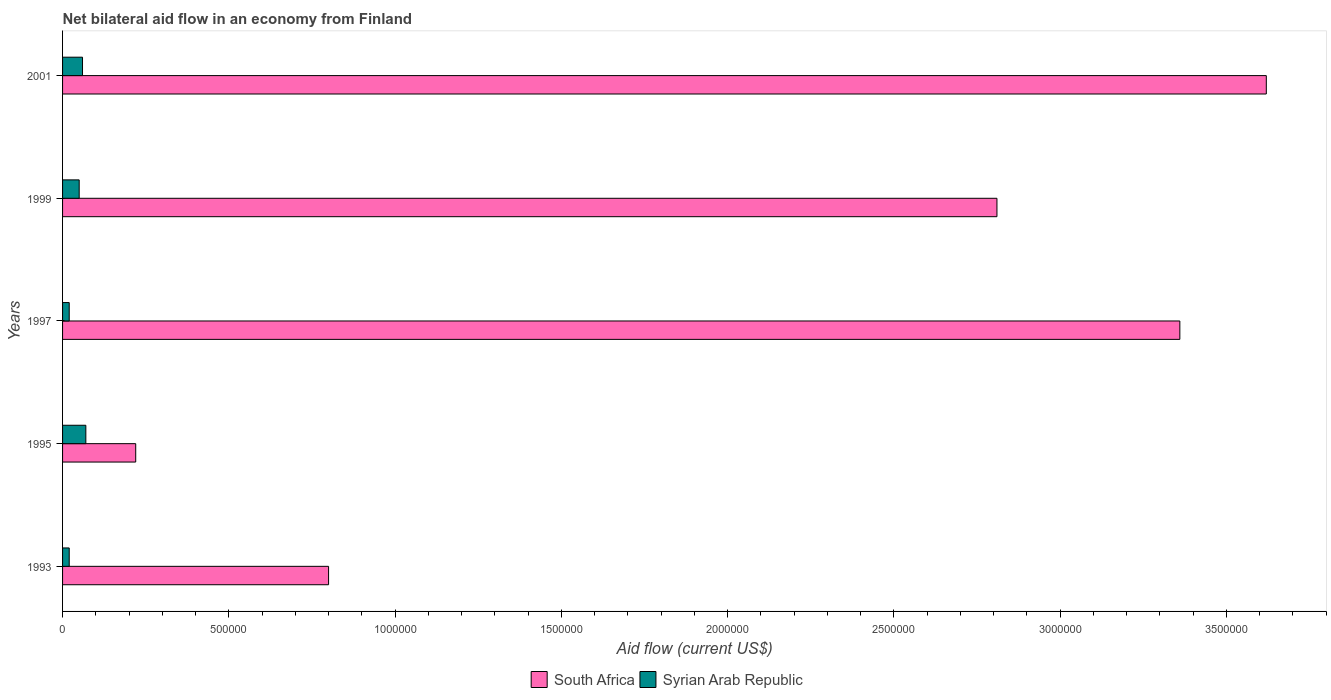How many different coloured bars are there?
Keep it short and to the point. 2. How many groups of bars are there?
Provide a succinct answer. 5. Are the number of bars on each tick of the Y-axis equal?
Offer a terse response. Yes. How many bars are there on the 2nd tick from the bottom?
Give a very brief answer. 2. What is the label of the 1st group of bars from the top?
Your answer should be very brief. 2001. Across all years, what is the maximum net bilateral aid flow in South Africa?
Ensure brevity in your answer.  3.62e+06. Across all years, what is the minimum net bilateral aid flow in South Africa?
Keep it short and to the point. 2.20e+05. What is the total net bilateral aid flow in South Africa in the graph?
Make the answer very short. 1.08e+07. What is the difference between the net bilateral aid flow in South Africa in 2001 and the net bilateral aid flow in Syrian Arab Republic in 1999?
Your answer should be compact. 3.57e+06. What is the average net bilateral aid flow in Syrian Arab Republic per year?
Your answer should be very brief. 4.40e+04. In the year 1997, what is the difference between the net bilateral aid flow in Syrian Arab Republic and net bilateral aid flow in South Africa?
Offer a terse response. -3.34e+06. What is the ratio of the net bilateral aid flow in South Africa in 1999 to that in 2001?
Your answer should be compact. 0.78. What is the difference between the highest and the second highest net bilateral aid flow in South Africa?
Offer a terse response. 2.60e+05. What is the difference between the highest and the lowest net bilateral aid flow in Syrian Arab Republic?
Ensure brevity in your answer.  5.00e+04. In how many years, is the net bilateral aid flow in South Africa greater than the average net bilateral aid flow in South Africa taken over all years?
Ensure brevity in your answer.  3. Is the sum of the net bilateral aid flow in South Africa in 1995 and 1999 greater than the maximum net bilateral aid flow in Syrian Arab Republic across all years?
Your answer should be compact. Yes. What does the 2nd bar from the top in 1999 represents?
Give a very brief answer. South Africa. What does the 2nd bar from the bottom in 1995 represents?
Offer a very short reply. Syrian Arab Republic. How many bars are there?
Make the answer very short. 10. How many years are there in the graph?
Ensure brevity in your answer.  5. What is the difference between two consecutive major ticks on the X-axis?
Your answer should be very brief. 5.00e+05. How many legend labels are there?
Keep it short and to the point. 2. How are the legend labels stacked?
Your response must be concise. Horizontal. What is the title of the graph?
Give a very brief answer. Net bilateral aid flow in an economy from Finland. Does "Mali" appear as one of the legend labels in the graph?
Your answer should be very brief. No. What is the Aid flow (current US$) of South Africa in 1995?
Keep it short and to the point. 2.20e+05. What is the Aid flow (current US$) of Syrian Arab Republic in 1995?
Keep it short and to the point. 7.00e+04. What is the Aid flow (current US$) of South Africa in 1997?
Keep it short and to the point. 3.36e+06. What is the Aid flow (current US$) in Syrian Arab Republic in 1997?
Offer a very short reply. 2.00e+04. What is the Aid flow (current US$) of South Africa in 1999?
Your response must be concise. 2.81e+06. What is the Aid flow (current US$) of South Africa in 2001?
Your answer should be compact. 3.62e+06. Across all years, what is the maximum Aid flow (current US$) of South Africa?
Ensure brevity in your answer.  3.62e+06. Across all years, what is the minimum Aid flow (current US$) of South Africa?
Make the answer very short. 2.20e+05. What is the total Aid flow (current US$) of South Africa in the graph?
Provide a short and direct response. 1.08e+07. What is the difference between the Aid flow (current US$) of South Africa in 1993 and that in 1995?
Give a very brief answer. 5.80e+05. What is the difference between the Aid flow (current US$) in Syrian Arab Republic in 1993 and that in 1995?
Your answer should be compact. -5.00e+04. What is the difference between the Aid flow (current US$) of South Africa in 1993 and that in 1997?
Provide a short and direct response. -2.56e+06. What is the difference between the Aid flow (current US$) in South Africa in 1993 and that in 1999?
Provide a succinct answer. -2.01e+06. What is the difference between the Aid flow (current US$) in South Africa in 1993 and that in 2001?
Your response must be concise. -2.82e+06. What is the difference between the Aid flow (current US$) in Syrian Arab Republic in 1993 and that in 2001?
Ensure brevity in your answer.  -4.00e+04. What is the difference between the Aid flow (current US$) in South Africa in 1995 and that in 1997?
Give a very brief answer. -3.14e+06. What is the difference between the Aid flow (current US$) in South Africa in 1995 and that in 1999?
Give a very brief answer. -2.59e+06. What is the difference between the Aid flow (current US$) in South Africa in 1995 and that in 2001?
Your response must be concise. -3.40e+06. What is the difference between the Aid flow (current US$) in South Africa in 1999 and that in 2001?
Your answer should be very brief. -8.10e+05. What is the difference between the Aid flow (current US$) in South Africa in 1993 and the Aid flow (current US$) in Syrian Arab Republic in 1995?
Offer a very short reply. 7.30e+05. What is the difference between the Aid flow (current US$) of South Africa in 1993 and the Aid flow (current US$) of Syrian Arab Republic in 1997?
Ensure brevity in your answer.  7.80e+05. What is the difference between the Aid flow (current US$) of South Africa in 1993 and the Aid flow (current US$) of Syrian Arab Republic in 1999?
Make the answer very short. 7.50e+05. What is the difference between the Aid flow (current US$) in South Africa in 1993 and the Aid flow (current US$) in Syrian Arab Republic in 2001?
Your response must be concise. 7.40e+05. What is the difference between the Aid flow (current US$) of South Africa in 1995 and the Aid flow (current US$) of Syrian Arab Republic in 1997?
Give a very brief answer. 2.00e+05. What is the difference between the Aid flow (current US$) in South Africa in 1995 and the Aid flow (current US$) in Syrian Arab Republic in 2001?
Give a very brief answer. 1.60e+05. What is the difference between the Aid flow (current US$) in South Africa in 1997 and the Aid flow (current US$) in Syrian Arab Republic in 1999?
Your answer should be very brief. 3.31e+06. What is the difference between the Aid flow (current US$) of South Africa in 1997 and the Aid flow (current US$) of Syrian Arab Republic in 2001?
Give a very brief answer. 3.30e+06. What is the difference between the Aid flow (current US$) of South Africa in 1999 and the Aid flow (current US$) of Syrian Arab Republic in 2001?
Offer a very short reply. 2.75e+06. What is the average Aid flow (current US$) in South Africa per year?
Your answer should be compact. 2.16e+06. What is the average Aid flow (current US$) in Syrian Arab Republic per year?
Ensure brevity in your answer.  4.40e+04. In the year 1993, what is the difference between the Aid flow (current US$) of South Africa and Aid flow (current US$) of Syrian Arab Republic?
Ensure brevity in your answer.  7.80e+05. In the year 1995, what is the difference between the Aid flow (current US$) of South Africa and Aid flow (current US$) of Syrian Arab Republic?
Keep it short and to the point. 1.50e+05. In the year 1997, what is the difference between the Aid flow (current US$) of South Africa and Aid flow (current US$) of Syrian Arab Republic?
Ensure brevity in your answer.  3.34e+06. In the year 1999, what is the difference between the Aid flow (current US$) in South Africa and Aid flow (current US$) in Syrian Arab Republic?
Ensure brevity in your answer.  2.76e+06. In the year 2001, what is the difference between the Aid flow (current US$) in South Africa and Aid flow (current US$) in Syrian Arab Republic?
Your answer should be very brief. 3.56e+06. What is the ratio of the Aid flow (current US$) in South Africa in 1993 to that in 1995?
Keep it short and to the point. 3.64. What is the ratio of the Aid flow (current US$) of Syrian Arab Republic in 1993 to that in 1995?
Your answer should be very brief. 0.29. What is the ratio of the Aid flow (current US$) in South Africa in 1993 to that in 1997?
Offer a very short reply. 0.24. What is the ratio of the Aid flow (current US$) of South Africa in 1993 to that in 1999?
Provide a succinct answer. 0.28. What is the ratio of the Aid flow (current US$) of South Africa in 1993 to that in 2001?
Your response must be concise. 0.22. What is the ratio of the Aid flow (current US$) of Syrian Arab Republic in 1993 to that in 2001?
Offer a very short reply. 0.33. What is the ratio of the Aid flow (current US$) in South Africa in 1995 to that in 1997?
Provide a succinct answer. 0.07. What is the ratio of the Aid flow (current US$) in Syrian Arab Republic in 1995 to that in 1997?
Offer a very short reply. 3.5. What is the ratio of the Aid flow (current US$) of South Africa in 1995 to that in 1999?
Your answer should be very brief. 0.08. What is the ratio of the Aid flow (current US$) in South Africa in 1995 to that in 2001?
Keep it short and to the point. 0.06. What is the ratio of the Aid flow (current US$) in Syrian Arab Republic in 1995 to that in 2001?
Provide a short and direct response. 1.17. What is the ratio of the Aid flow (current US$) in South Africa in 1997 to that in 1999?
Provide a succinct answer. 1.2. What is the ratio of the Aid flow (current US$) in South Africa in 1997 to that in 2001?
Offer a very short reply. 0.93. What is the ratio of the Aid flow (current US$) of South Africa in 1999 to that in 2001?
Provide a short and direct response. 0.78. What is the difference between the highest and the lowest Aid flow (current US$) in South Africa?
Provide a short and direct response. 3.40e+06. What is the difference between the highest and the lowest Aid flow (current US$) of Syrian Arab Republic?
Offer a very short reply. 5.00e+04. 